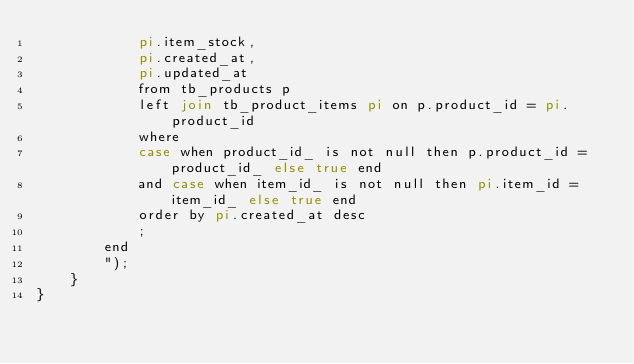<code> <loc_0><loc_0><loc_500><loc_500><_PHP_>            pi.item_stock,
            pi.created_at,
            pi.updated_at
            from tb_products p
            left join tb_product_items pi on p.product_id = pi.product_id
            where
            case when product_id_ is not null then p.product_id = product_id_ else true end
            and case when item_id_ is not null then pi.item_id = item_id_ else true end 
            order by pi.created_at desc
            ;
        end
        ");
    }
}
</code> 